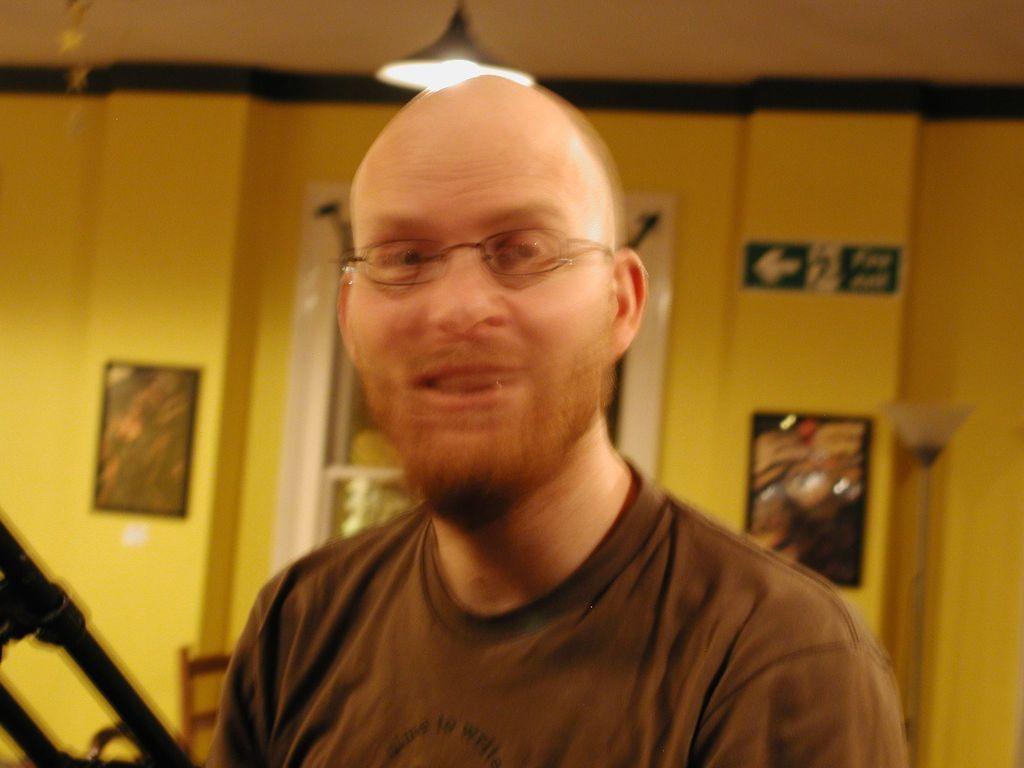Can you describe this image briefly? In the image we can see there is a man and he is wearing spectacles. Behind there are photo frames on the wall and there is a light on the top. The image is little blurred. 